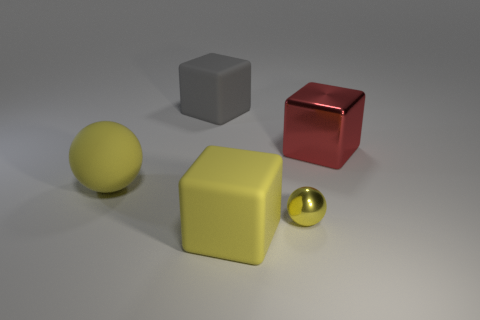What number of other things are the same color as the small ball?
Ensure brevity in your answer.  2. What is the material of the big thing that is the same color as the rubber ball?
Provide a short and direct response. Rubber. What is the size of the rubber cube that is the same color as the tiny metal ball?
Ensure brevity in your answer.  Large. The large rubber object that is behind the tiny yellow object and in front of the big red metal block has what shape?
Offer a terse response. Sphere. There is a red metallic thing; what number of large red cubes are right of it?
Offer a terse response. 0. What number of other things are the same shape as the red object?
Give a very brief answer. 2. Are there fewer large gray cylinders than small yellow shiny things?
Your answer should be compact. Yes. There is a thing that is behind the big yellow rubber sphere and right of the large yellow cube; how big is it?
Your response must be concise. Large. There is a yellow sphere to the right of the yellow sphere that is left of the big cube in front of the large yellow matte sphere; what size is it?
Provide a short and direct response. Small. How big is the yellow metal ball?
Your answer should be compact. Small. 